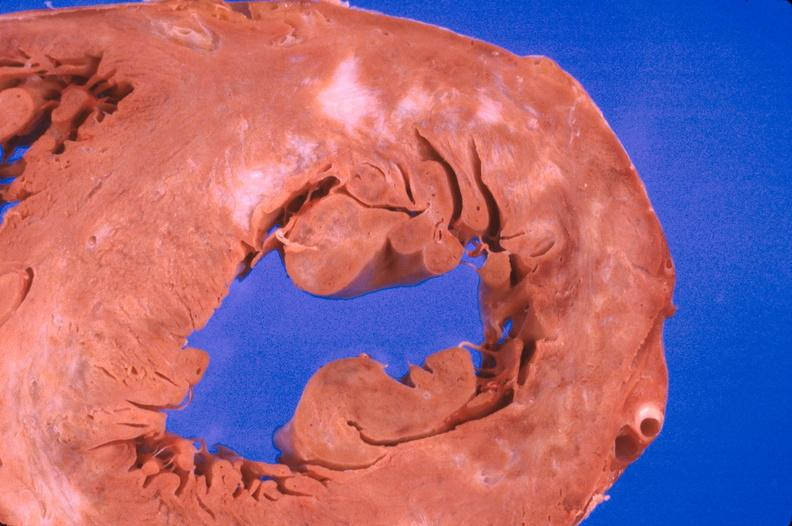s beckwith-wiedemann syndrome present?
Answer the question using a single word or phrase. No 